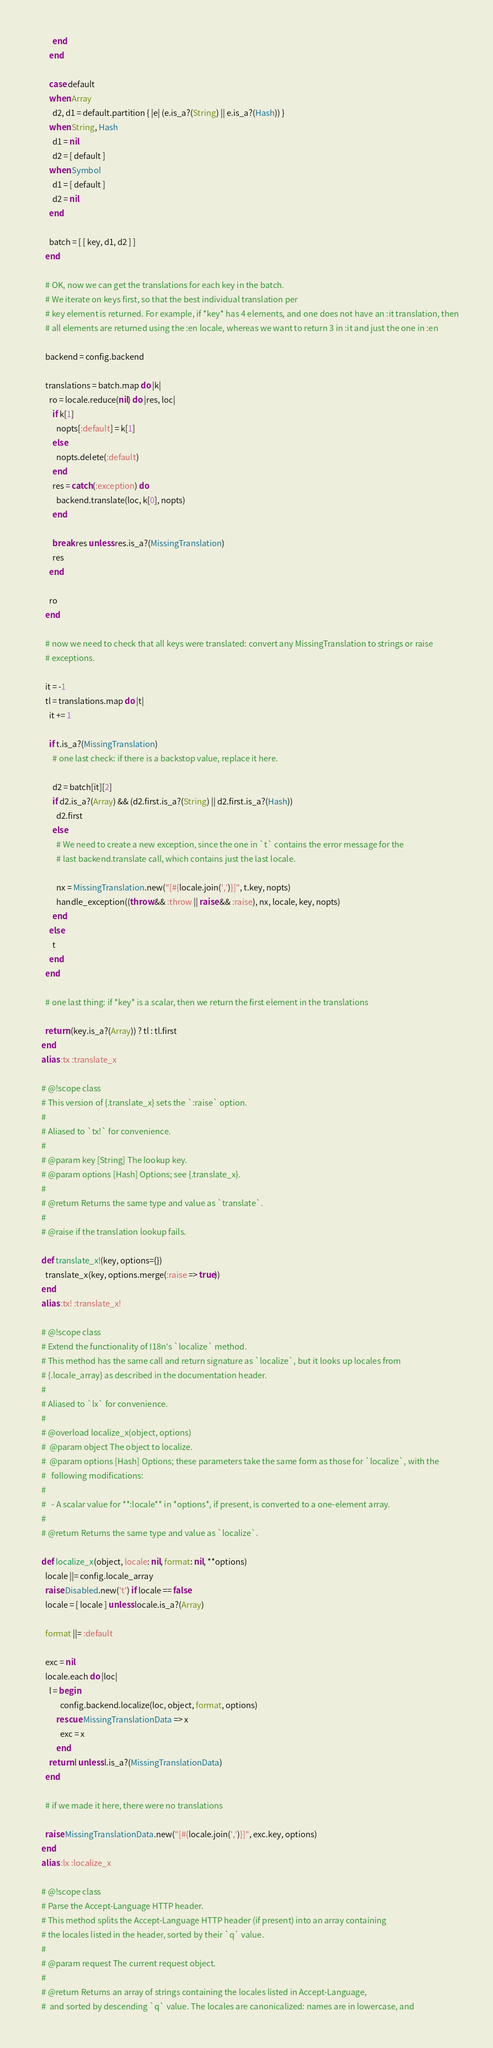<code> <loc_0><loc_0><loc_500><loc_500><_Ruby_>          end
        end

        case default
        when Array
          d2, d1 = default.partition { |e| (e.is_a?(String) || e.is_a?(Hash)) }
        when String, Hash
          d1 = nil
          d2 = [ default ]
        when Symbol
          d1 = [ default ]
          d2 = nil
        end

        batch = [ [ key, d1, d2 ] ]
      end

      # OK, now we can get the translations for each key in the batch.
      # We iterate on keys first, so that the best individual translation per
      # key element is returned. For example, if *key* has 4 elements, and one does not have an :it translation, then
      # all elements are returned using the :en locale, whereas we want to return 3 in :it and just the one in :en

      backend = config.backend

      translations = batch.map do |k|
        ro = locale.reduce(nil) do |res, loc|
          if k[1]
            nopts[:default] = k[1]
          else
            nopts.delete(:default)
          end
          res = catch(:exception) do
            backend.translate(loc, k[0], nopts)
          end

          break res unless res.is_a?(MissingTranslation)
          res
        end

        ro
      end

      # now we need to check that all keys were translated: convert any MissingTranslation to strings or raise
      # exceptions.

      it = -1
      tl = translations.map do |t|
        it += 1
        
        if t.is_a?(MissingTranslation)
          # one last check: if there is a backstop value, replace it here.

          d2 = batch[it][2]
          if d2.is_a?(Array) && (d2.first.is_a?(String) || d2.first.is_a?(Hash))
            d2.first
          else
            # We need to create a new exception, since the one in `t` contains the error message for the
            # last backend.translate call, which contains just the last locale.

            nx = MissingTranslation.new("[#{locale.join(',')}]", t.key, nopts)
            handle_exception((throw && :throw || raise && :raise), nx, locale, key, nopts)
          end
        else
          t
        end
      end

      # one last thing: if *key* is a scalar, then we return the first element in the translations

      return (key.is_a?(Array)) ? tl : tl.first
    end
    alias :tx :translate_x
    
    # @!scope class
    # This version of {.translate_x} sets the `:raise` option.
    #
    # Aliased to `tx!` for convenience.
    #
    # @param key [String] The lookup key.
    # @param options [Hash] Options; see {.translate_x}.
    #
    # @return Returns the same type and value as `translate`.
    #
    # @raise if the translation lookup fails.

    def translate_x!(key, options={})
      translate_x(key, options.merge(:raise => true))
    end
    alias :tx! :translate_x!

    # @!scope class
    # Extend the functionality of I18n's `localize` method.
    # This method has the same call and return signature as `localize`, but it looks up locales from
    # {.locale_array} as described in the documentation header.
    #
    # Aliased to `lx` for convenience.
    #
    # @overload localize_x(object, options)
    #  @param object The object to localize.
    #  @param options [Hash] Options; these parameters take the same form as those for `localize`, with the
    #   following modifications:
    #
    #   - A scalar value for **:locale** in *options*, if present, is converted to a one-element array.
    #
    # @return Returns the same type and value as `localize`.

    def localize_x(object, locale: nil, format: nil, **options)
      locale ||= config.locale_array
      raise Disabled.new('t') if locale == false
      locale = [ locale ] unless locale.is_a?(Array)

      format ||= :default

      exc = nil
      locale.each do |loc|
        l = begin
              config.backend.localize(loc, object, format, options)
            rescue MissingTranslationData => x
              exc = x
            end
        return l unless l.is_a?(MissingTranslationData)
      end

      # if we made it here, there were no translations

      raise MissingTranslationData.new("[#{locale.join(',')}]", exc.key, options)
    end
    alias :lx :localize_x

    # @!scope class
    # Parse the Accept-Language HTTP header.
    # This method splits the Accept-Language HTTP header (if present) into an array containing
    # the locales listed in the header, sorted by their `q` value.
    #
    # @param request The current request object.
    #
    # @return Returns an array of strings containing the locales listed in Accept-Language,
    #  and sorted by descending `q` value. The locales are canonicalized: names are in lowercase, and </code> 